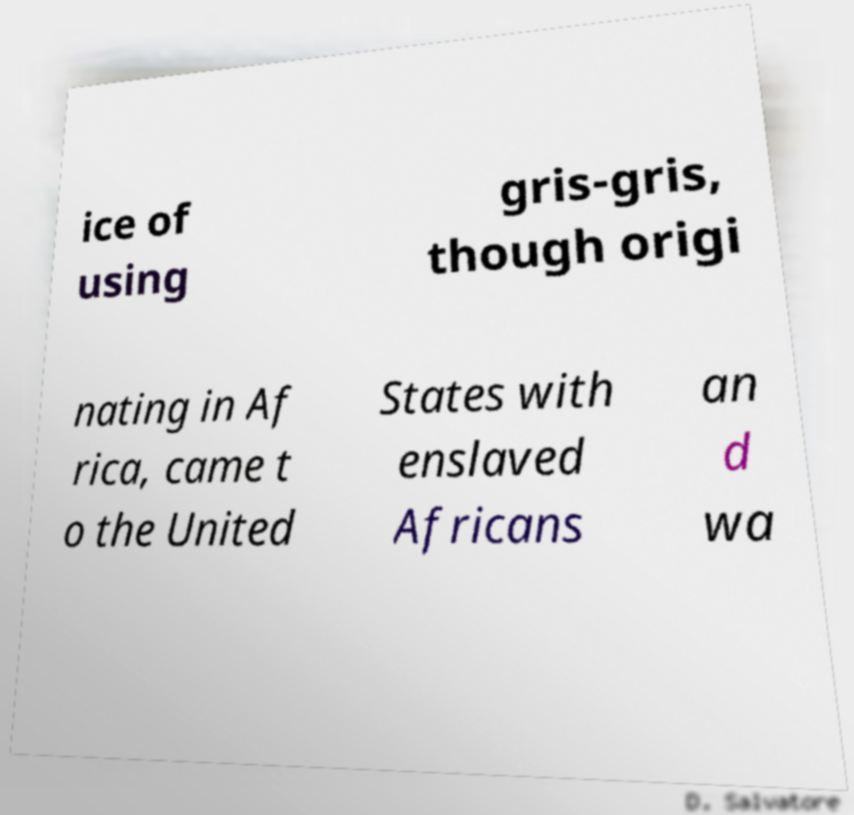For documentation purposes, I need the text within this image transcribed. Could you provide that? ice of using gris-gris, though origi nating in Af rica, came t o the United States with enslaved Africans an d wa 